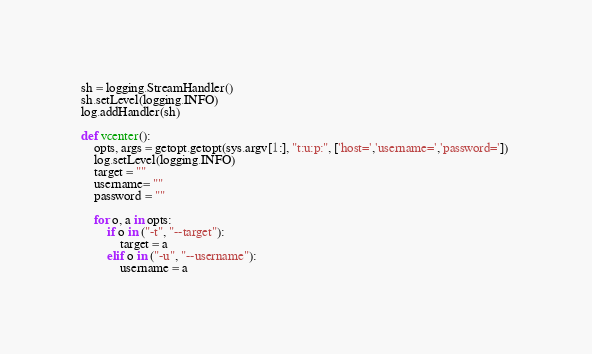<code> <loc_0><loc_0><loc_500><loc_500><_Python_>sh = logging.StreamHandler()
sh.setLevel(logging.INFO)
log.addHandler(sh)

def vcenter():
    opts, args = getopt.getopt(sys.argv[1:], "t:u:p:", ['host=','username=','password=']) 
    log.setLevel(logging.INFO)
    target = ""
    username= ""
    password = ""
    
    for o, a in opts:
        if o in ("-t", "--target"):
            target = a
        elif o in ("-u", "--username"):
            username = a</code> 